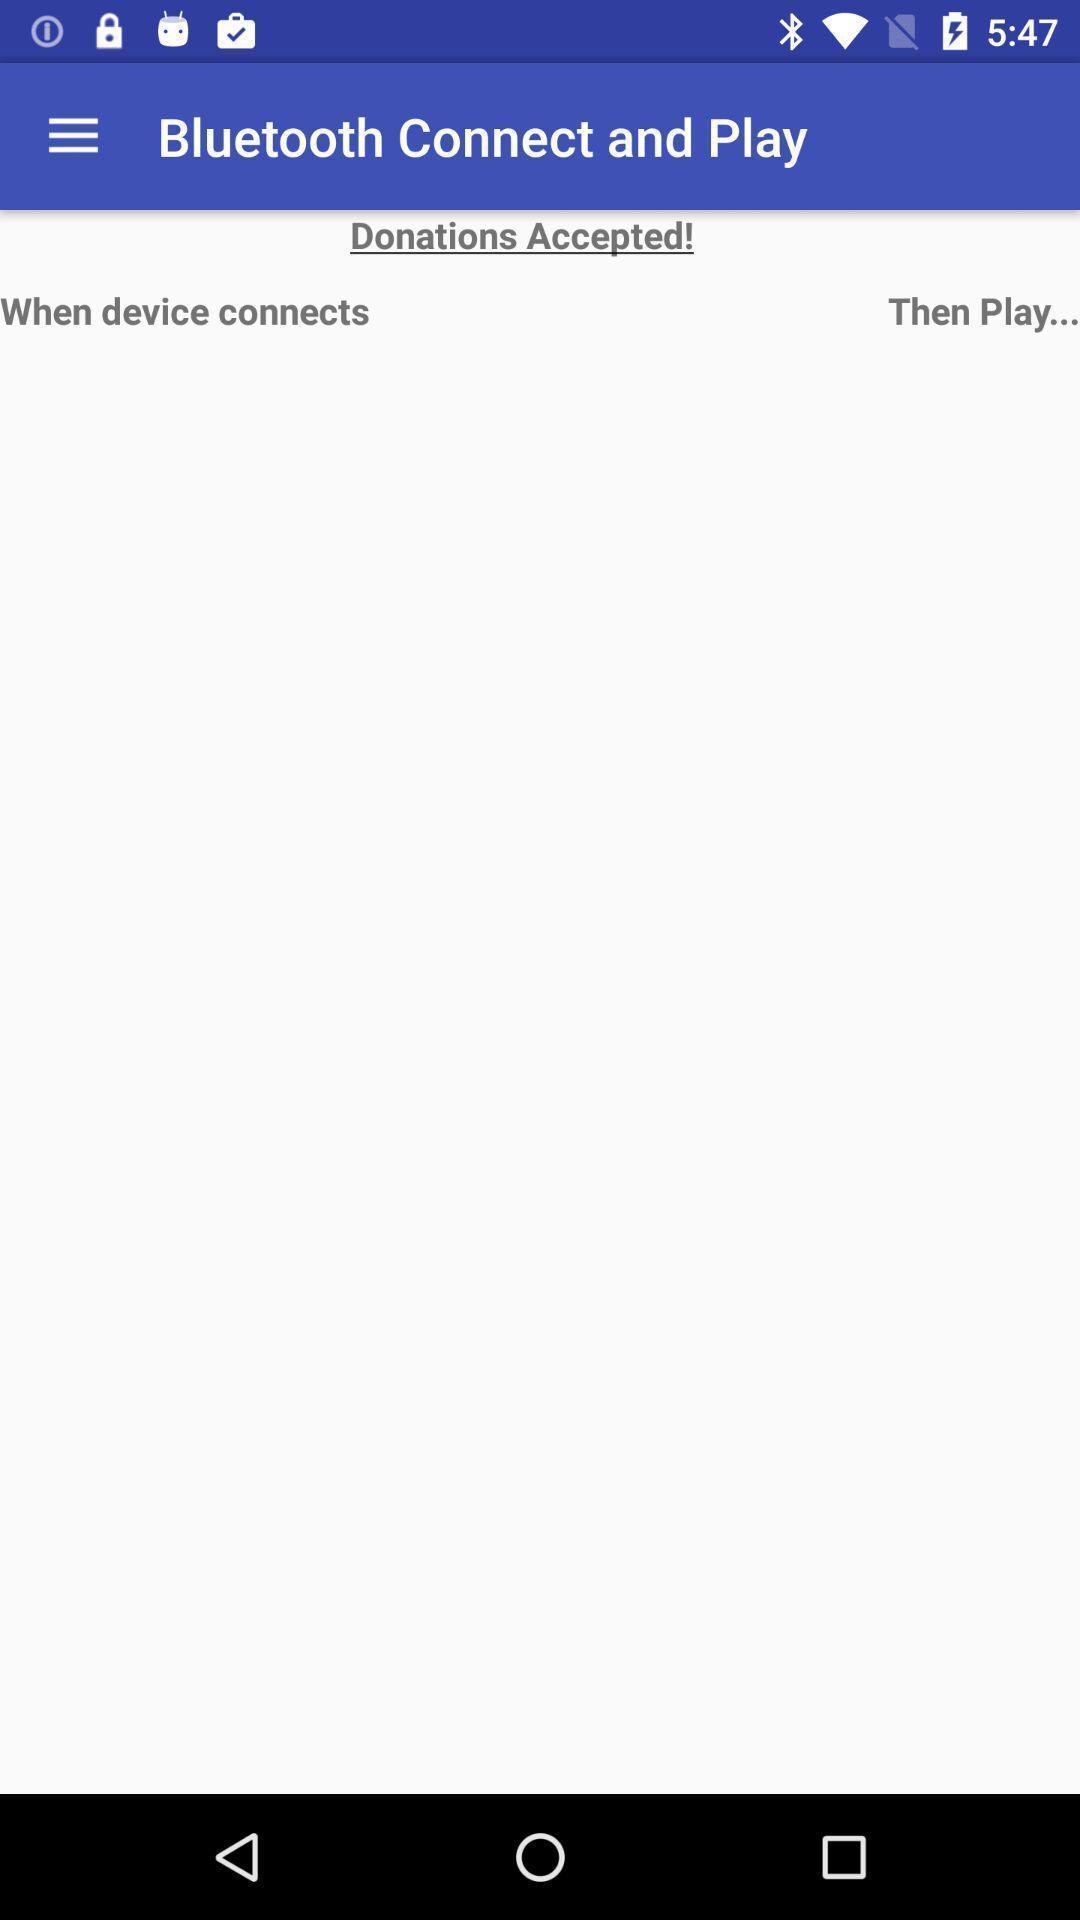Summarize the main components in this picture. Screen showing donations accepted. 